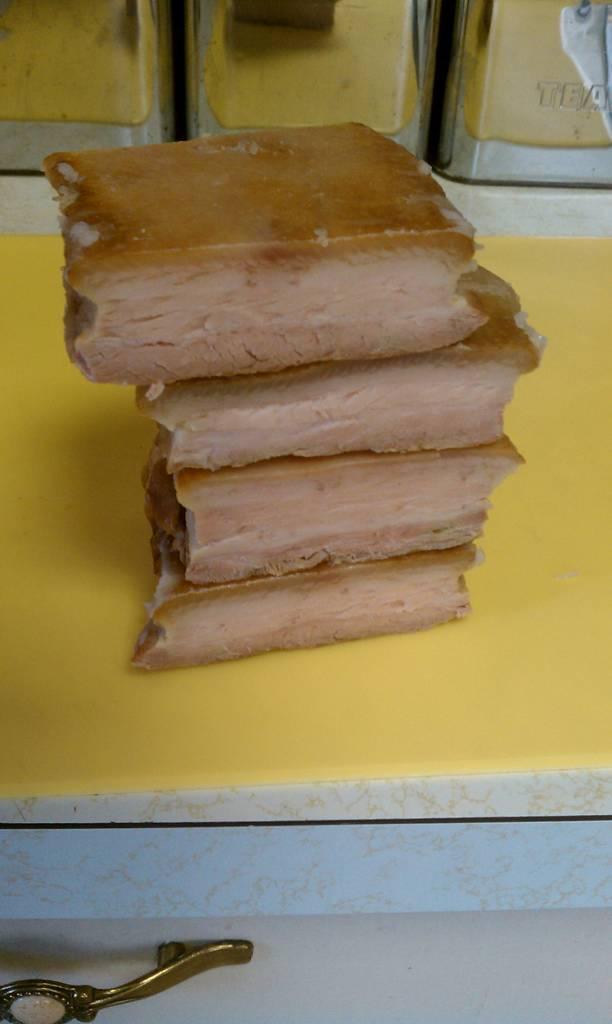Could you give a brief overview of what you see in this image? In the center of the image we can see bread placed on the table. 